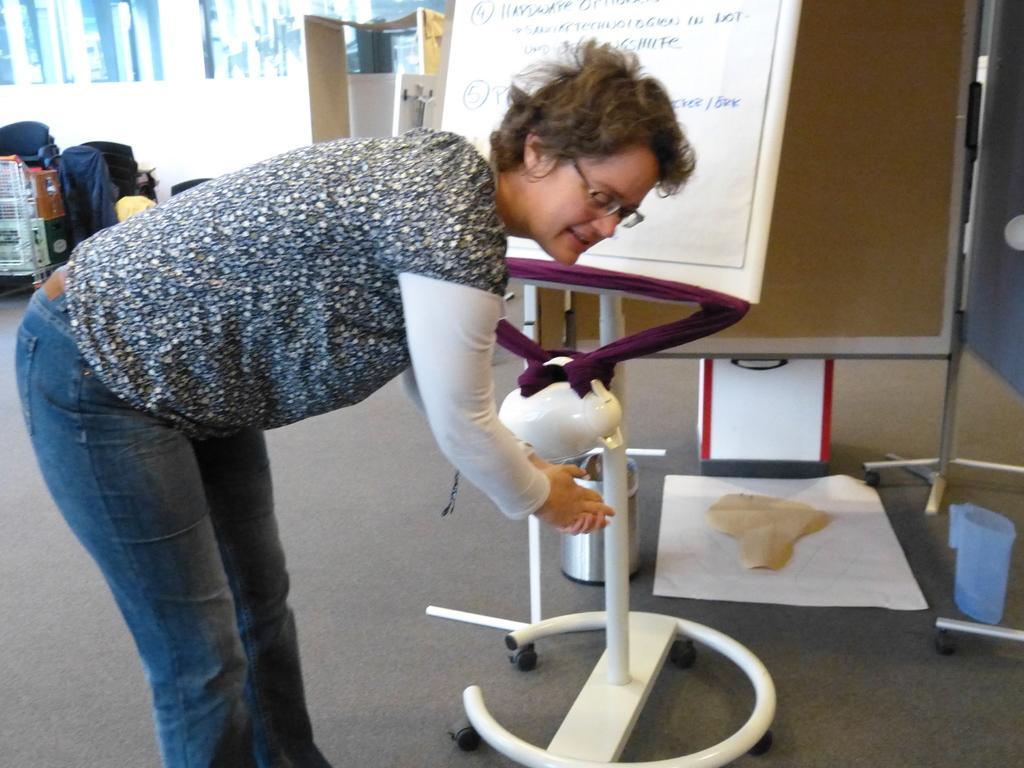Describe this image in one or two sentences. In this picture I can see a person standing, there are papers, boards, a jug , and in the background there are chairs and some other items. 